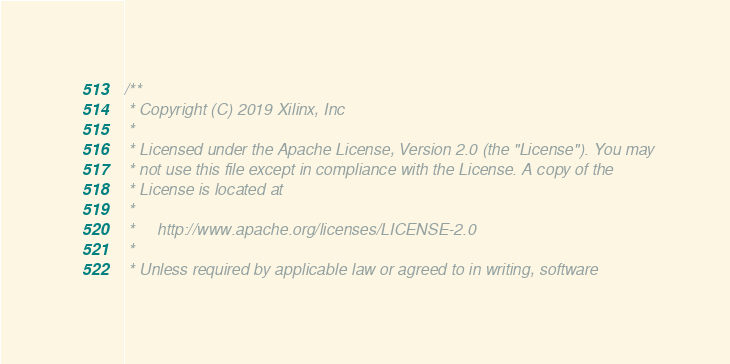<code> <loc_0><loc_0><loc_500><loc_500><_C_>/**
 * Copyright (C) 2019 Xilinx, Inc
 *
 * Licensed under the Apache License, Version 2.0 (the "License"). You may
 * not use this file except in compliance with the License. A copy of the
 * License is located at
 *
 *     http://www.apache.org/licenses/LICENSE-2.0
 *
 * Unless required by applicable law or agreed to in writing, software</code> 